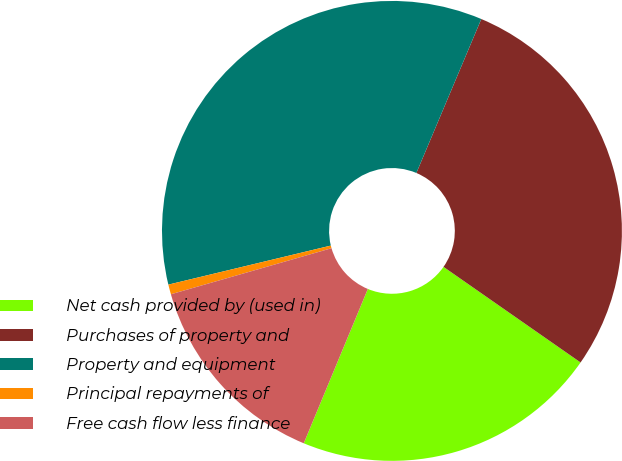Convert chart. <chart><loc_0><loc_0><loc_500><loc_500><pie_chart><fcel>Net cash provided by (used in)<fcel>Purchases of property and<fcel>Property and equipment<fcel>Principal repayments of<fcel>Free cash flow less finance<nl><fcel>21.57%<fcel>28.34%<fcel>35.1%<fcel>0.69%<fcel>14.29%<nl></chart> 